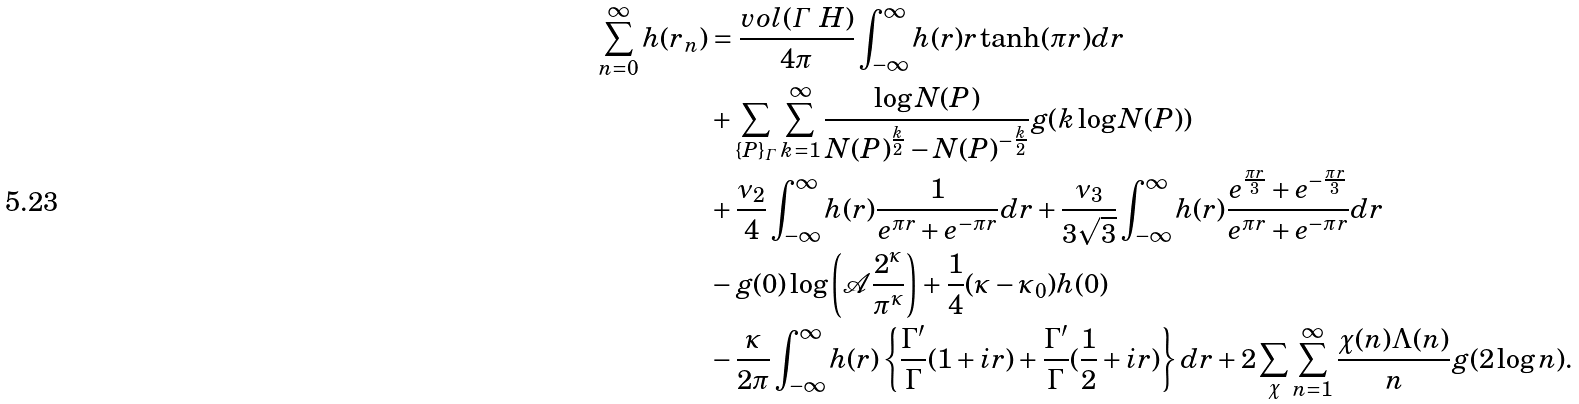<formula> <loc_0><loc_0><loc_500><loc_500>\sum _ { n = 0 } ^ { \infty } h ( r _ { n } ) & = \frac { v o l ( \varGamma \ H ) } { 4 \pi } \int _ { - \infty } ^ { \infty } h ( r ) r \tanh ( \pi r ) d r \\ & + \sum _ { \{ P \} _ { \varGamma } } \sum _ { k = 1 } ^ { \infty } \frac { \log N ( P ) } { N ( P ) ^ { \frac { k } { 2 } } - N ( P ) ^ { - \frac { k } { 2 } } } g ( k \log N ( P ) ) \\ & + \frac { \nu _ { 2 } } { 4 } \int _ { - \infty } ^ { \infty } h ( r ) \frac { 1 } { e ^ { \pi r } + e ^ { - \pi r } } d r + \frac { \nu _ { 3 } } { 3 \sqrt { 3 } } \int _ { - \infty } ^ { \infty } h ( r ) \frac { e ^ { \frac { \pi r } { 3 } } + e ^ { - \frac { \pi r } { 3 } } } { e ^ { \pi r } + e ^ { - \pi r } } d r \\ & - g ( 0 ) \log \left ( \mathcal { A } \frac { 2 ^ { \kappa } } { \pi ^ { \kappa } } \right ) + \frac { 1 } { 4 } ( \kappa - \kappa _ { 0 } ) h ( 0 ) \\ & - \frac { \kappa } { 2 \pi } \int _ { - \infty } ^ { \infty } h ( r ) \left \{ \frac { \Gamma ^ { \prime } } { \Gamma } ( 1 + i r ) + \frac { \Gamma ^ { \prime } } { \Gamma } ( \frac { 1 } { 2 } + i r ) \right \} d r + 2 \sum _ { \chi } \sum _ { n = 1 } ^ { \infty } \frac { \chi ( n ) \Lambda ( n ) } { n } g ( 2 \log n ) .</formula> 